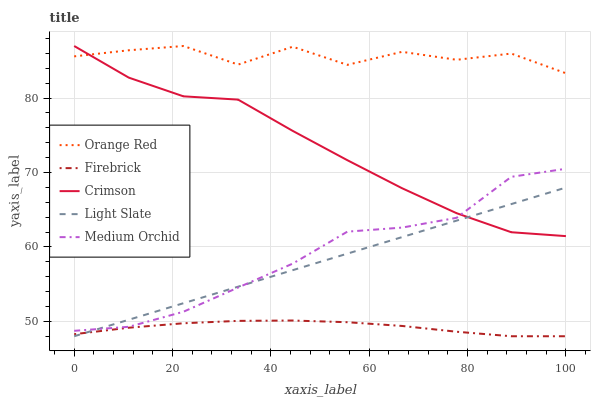Does Firebrick have the minimum area under the curve?
Answer yes or no. Yes. Does Orange Red have the maximum area under the curve?
Answer yes or no. Yes. Does Light Slate have the minimum area under the curve?
Answer yes or no. No. Does Light Slate have the maximum area under the curve?
Answer yes or no. No. Is Light Slate the smoothest?
Answer yes or no. Yes. Is Orange Red the roughest?
Answer yes or no. Yes. Is Firebrick the smoothest?
Answer yes or no. No. Is Firebrick the roughest?
Answer yes or no. No. Does Light Slate have the lowest value?
Answer yes or no. Yes. Does Medium Orchid have the lowest value?
Answer yes or no. No. Does Orange Red have the highest value?
Answer yes or no. Yes. Does Light Slate have the highest value?
Answer yes or no. No. Is Light Slate less than Orange Red?
Answer yes or no. Yes. Is Medium Orchid greater than Firebrick?
Answer yes or no. Yes. Does Crimson intersect Orange Red?
Answer yes or no. Yes. Is Crimson less than Orange Red?
Answer yes or no. No. Is Crimson greater than Orange Red?
Answer yes or no. No. Does Light Slate intersect Orange Red?
Answer yes or no. No. 